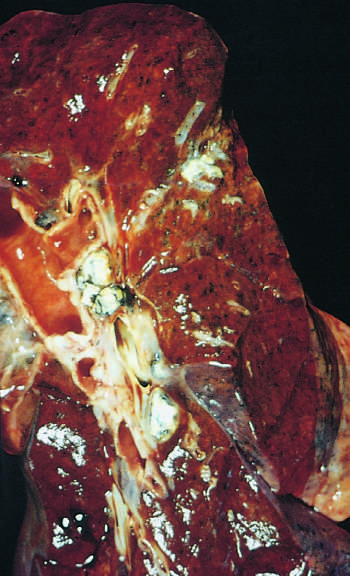what are seen left?
Answer the question using a single word or phrase. Hilar lymph nodes with caseation 